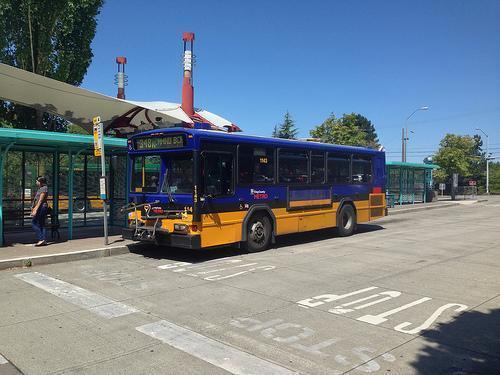How many buses are there?
Give a very brief answer. 1. 